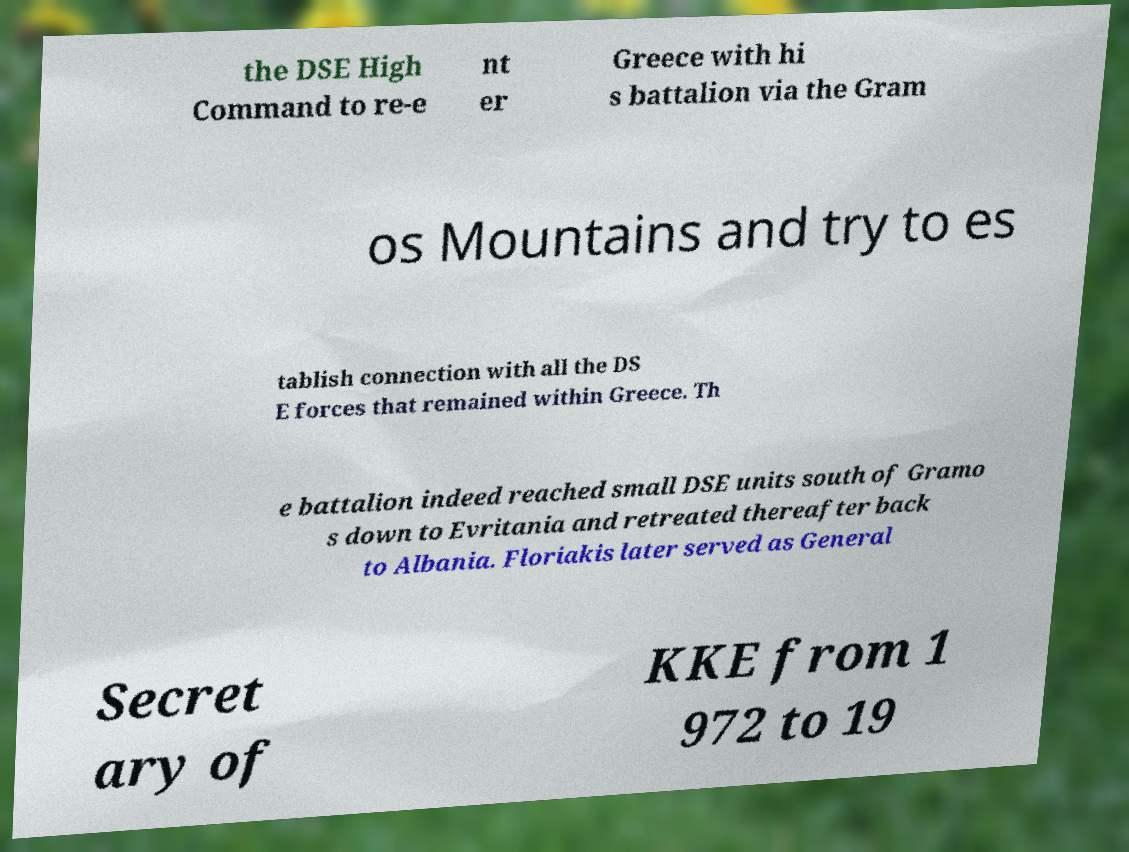For documentation purposes, I need the text within this image transcribed. Could you provide that? the DSE High Command to re-e nt er Greece with hi s battalion via the Gram os Mountains and try to es tablish connection with all the DS E forces that remained within Greece. Th e battalion indeed reached small DSE units south of Gramo s down to Evritania and retreated thereafter back to Albania. Floriakis later served as General Secret ary of KKE from 1 972 to 19 